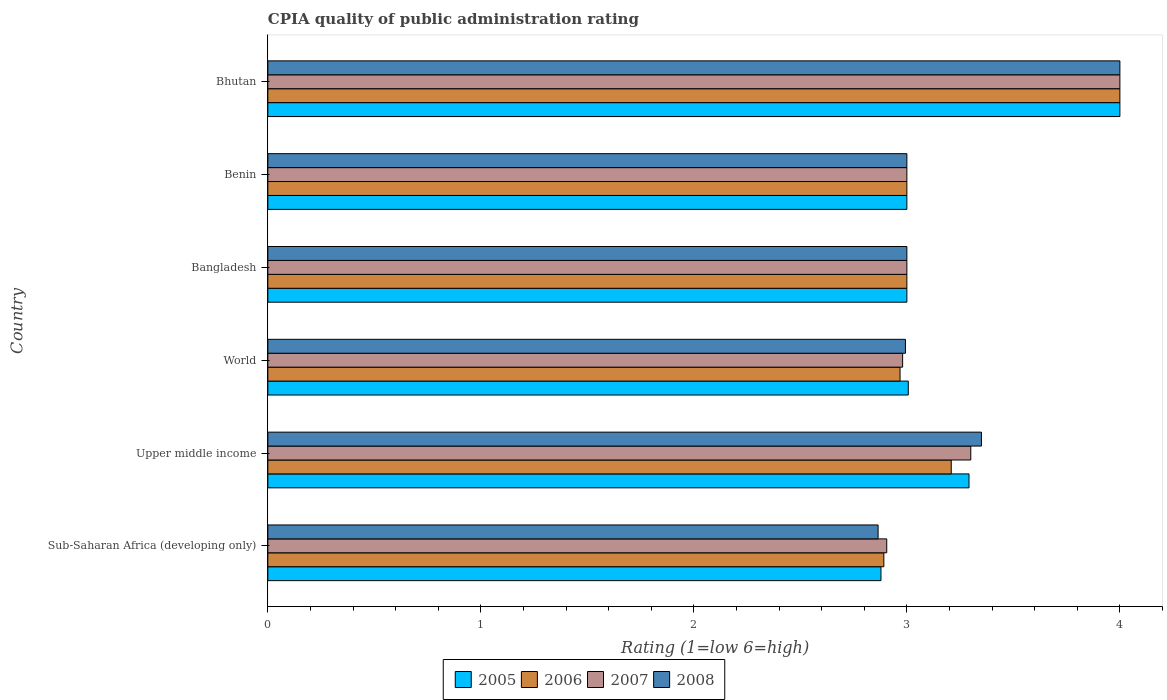Are the number of bars per tick equal to the number of legend labels?
Provide a short and direct response. Yes. How many bars are there on the 4th tick from the top?
Offer a terse response. 4. What is the label of the 2nd group of bars from the top?
Ensure brevity in your answer.  Benin. What is the CPIA rating in 2005 in World?
Your answer should be very brief. 3.01. Across all countries, what is the maximum CPIA rating in 2007?
Your answer should be compact. 4. Across all countries, what is the minimum CPIA rating in 2006?
Make the answer very short. 2.89. In which country was the CPIA rating in 2005 maximum?
Provide a succinct answer. Bhutan. In which country was the CPIA rating in 2007 minimum?
Your answer should be compact. Sub-Saharan Africa (developing only). What is the total CPIA rating in 2006 in the graph?
Your response must be concise. 19.07. What is the difference between the CPIA rating in 2007 in Sub-Saharan Africa (developing only) and that in Upper middle income?
Your response must be concise. -0.39. What is the difference between the CPIA rating in 2008 in Sub-Saharan Africa (developing only) and the CPIA rating in 2007 in Upper middle income?
Offer a terse response. -0.44. What is the average CPIA rating in 2006 per country?
Offer a terse response. 3.18. What is the difference between the CPIA rating in 2007 and CPIA rating in 2008 in Sub-Saharan Africa (developing only)?
Your answer should be very brief. 0.04. What is the ratio of the CPIA rating in 2006 in Sub-Saharan Africa (developing only) to that in Upper middle income?
Provide a succinct answer. 0.9. Is the CPIA rating in 2006 in Bhutan less than that in Upper middle income?
Your answer should be very brief. No. What is the difference between the highest and the second highest CPIA rating in 2006?
Offer a very short reply. 0.79. What is the difference between the highest and the lowest CPIA rating in 2005?
Your answer should be compact. 1.12. In how many countries, is the CPIA rating in 2008 greater than the average CPIA rating in 2008 taken over all countries?
Offer a very short reply. 2. Is the sum of the CPIA rating in 2008 in Sub-Saharan Africa (developing only) and World greater than the maximum CPIA rating in 2007 across all countries?
Give a very brief answer. Yes. Is it the case that in every country, the sum of the CPIA rating in 2007 and CPIA rating in 2006 is greater than the sum of CPIA rating in 2005 and CPIA rating in 2008?
Make the answer very short. No. What does the 2nd bar from the top in Bangladesh represents?
Keep it short and to the point. 2007. What does the 2nd bar from the bottom in Upper middle income represents?
Make the answer very short. 2006. How many countries are there in the graph?
Your answer should be very brief. 6. What is the difference between two consecutive major ticks on the X-axis?
Make the answer very short. 1. Where does the legend appear in the graph?
Your response must be concise. Bottom center. What is the title of the graph?
Your answer should be compact. CPIA quality of public administration rating. Does "1982" appear as one of the legend labels in the graph?
Your answer should be compact. No. What is the label or title of the Y-axis?
Your response must be concise. Country. What is the Rating (1=low 6=high) in 2005 in Sub-Saharan Africa (developing only)?
Your response must be concise. 2.88. What is the Rating (1=low 6=high) of 2006 in Sub-Saharan Africa (developing only)?
Keep it short and to the point. 2.89. What is the Rating (1=low 6=high) in 2007 in Sub-Saharan Africa (developing only)?
Your response must be concise. 2.91. What is the Rating (1=low 6=high) of 2008 in Sub-Saharan Africa (developing only)?
Keep it short and to the point. 2.86. What is the Rating (1=low 6=high) in 2005 in Upper middle income?
Make the answer very short. 3.29. What is the Rating (1=low 6=high) of 2006 in Upper middle income?
Keep it short and to the point. 3.21. What is the Rating (1=low 6=high) in 2008 in Upper middle income?
Your answer should be compact. 3.35. What is the Rating (1=low 6=high) in 2005 in World?
Provide a succinct answer. 3.01. What is the Rating (1=low 6=high) of 2006 in World?
Provide a succinct answer. 2.97. What is the Rating (1=low 6=high) in 2007 in World?
Make the answer very short. 2.98. What is the Rating (1=low 6=high) of 2008 in World?
Provide a succinct answer. 2.99. What is the Rating (1=low 6=high) in 2005 in Bangladesh?
Offer a terse response. 3. What is the Rating (1=low 6=high) in 2006 in Bangladesh?
Ensure brevity in your answer.  3. What is the Rating (1=low 6=high) of 2007 in Bangladesh?
Offer a very short reply. 3. What is the Rating (1=low 6=high) in 2008 in Bangladesh?
Provide a succinct answer. 3. What is the Rating (1=low 6=high) of 2006 in Benin?
Provide a short and direct response. 3. What is the Rating (1=low 6=high) of 2007 in Benin?
Your answer should be compact. 3. What is the Rating (1=low 6=high) of 2008 in Benin?
Offer a terse response. 3. What is the Rating (1=low 6=high) in 2005 in Bhutan?
Give a very brief answer. 4. What is the Rating (1=low 6=high) of 2007 in Bhutan?
Your answer should be very brief. 4. What is the Rating (1=low 6=high) of 2008 in Bhutan?
Provide a short and direct response. 4. Across all countries, what is the maximum Rating (1=low 6=high) in 2005?
Your answer should be very brief. 4. Across all countries, what is the maximum Rating (1=low 6=high) in 2007?
Your answer should be compact. 4. Across all countries, what is the maximum Rating (1=low 6=high) of 2008?
Ensure brevity in your answer.  4. Across all countries, what is the minimum Rating (1=low 6=high) of 2005?
Offer a terse response. 2.88. Across all countries, what is the minimum Rating (1=low 6=high) in 2006?
Make the answer very short. 2.89. Across all countries, what is the minimum Rating (1=low 6=high) in 2007?
Keep it short and to the point. 2.91. Across all countries, what is the minimum Rating (1=low 6=high) of 2008?
Your response must be concise. 2.86. What is the total Rating (1=low 6=high) of 2005 in the graph?
Make the answer very short. 19.18. What is the total Rating (1=low 6=high) of 2006 in the graph?
Keep it short and to the point. 19.07. What is the total Rating (1=low 6=high) of 2007 in the graph?
Your answer should be very brief. 19.19. What is the total Rating (1=low 6=high) in 2008 in the graph?
Provide a succinct answer. 19.21. What is the difference between the Rating (1=low 6=high) in 2005 in Sub-Saharan Africa (developing only) and that in Upper middle income?
Offer a terse response. -0.41. What is the difference between the Rating (1=low 6=high) in 2006 in Sub-Saharan Africa (developing only) and that in Upper middle income?
Your answer should be compact. -0.32. What is the difference between the Rating (1=low 6=high) in 2007 in Sub-Saharan Africa (developing only) and that in Upper middle income?
Your response must be concise. -0.39. What is the difference between the Rating (1=low 6=high) in 2008 in Sub-Saharan Africa (developing only) and that in Upper middle income?
Your answer should be compact. -0.49. What is the difference between the Rating (1=low 6=high) in 2005 in Sub-Saharan Africa (developing only) and that in World?
Your response must be concise. -0.13. What is the difference between the Rating (1=low 6=high) of 2006 in Sub-Saharan Africa (developing only) and that in World?
Provide a short and direct response. -0.08. What is the difference between the Rating (1=low 6=high) in 2007 in Sub-Saharan Africa (developing only) and that in World?
Provide a succinct answer. -0.07. What is the difference between the Rating (1=low 6=high) of 2008 in Sub-Saharan Africa (developing only) and that in World?
Your answer should be very brief. -0.13. What is the difference between the Rating (1=low 6=high) in 2005 in Sub-Saharan Africa (developing only) and that in Bangladesh?
Provide a short and direct response. -0.12. What is the difference between the Rating (1=low 6=high) of 2006 in Sub-Saharan Africa (developing only) and that in Bangladesh?
Provide a short and direct response. -0.11. What is the difference between the Rating (1=low 6=high) in 2007 in Sub-Saharan Africa (developing only) and that in Bangladesh?
Provide a short and direct response. -0.09. What is the difference between the Rating (1=low 6=high) of 2008 in Sub-Saharan Africa (developing only) and that in Bangladesh?
Your answer should be compact. -0.14. What is the difference between the Rating (1=low 6=high) of 2005 in Sub-Saharan Africa (developing only) and that in Benin?
Make the answer very short. -0.12. What is the difference between the Rating (1=low 6=high) in 2006 in Sub-Saharan Africa (developing only) and that in Benin?
Offer a very short reply. -0.11. What is the difference between the Rating (1=low 6=high) of 2007 in Sub-Saharan Africa (developing only) and that in Benin?
Offer a terse response. -0.09. What is the difference between the Rating (1=low 6=high) of 2008 in Sub-Saharan Africa (developing only) and that in Benin?
Offer a terse response. -0.14. What is the difference between the Rating (1=low 6=high) of 2005 in Sub-Saharan Africa (developing only) and that in Bhutan?
Your response must be concise. -1.12. What is the difference between the Rating (1=low 6=high) in 2006 in Sub-Saharan Africa (developing only) and that in Bhutan?
Provide a succinct answer. -1.11. What is the difference between the Rating (1=low 6=high) of 2007 in Sub-Saharan Africa (developing only) and that in Bhutan?
Offer a terse response. -1.09. What is the difference between the Rating (1=low 6=high) in 2008 in Sub-Saharan Africa (developing only) and that in Bhutan?
Offer a terse response. -1.14. What is the difference between the Rating (1=low 6=high) of 2005 in Upper middle income and that in World?
Give a very brief answer. 0.29. What is the difference between the Rating (1=low 6=high) in 2006 in Upper middle income and that in World?
Your response must be concise. 0.24. What is the difference between the Rating (1=low 6=high) of 2007 in Upper middle income and that in World?
Your response must be concise. 0.32. What is the difference between the Rating (1=low 6=high) of 2008 in Upper middle income and that in World?
Give a very brief answer. 0.36. What is the difference between the Rating (1=low 6=high) of 2005 in Upper middle income and that in Bangladesh?
Give a very brief answer. 0.29. What is the difference between the Rating (1=low 6=high) in 2006 in Upper middle income and that in Bangladesh?
Your answer should be very brief. 0.21. What is the difference between the Rating (1=low 6=high) of 2008 in Upper middle income and that in Bangladesh?
Keep it short and to the point. 0.35. What is the difference between the Rating (1=low 6=high) in 2005 in Upper middle income and that in Benin?
Offer a very short reply. 0.29. What is the difference between the Rating (1=low 6=high) in 2006 in Upper middle income and that in Benin?
Offer a terse response. 0.21. What is the difference between the Rating (1=low 6=high) in 2005 in Upper middle income and that in Bhutan?
Your answer should be compact. -0.71. What is the difference between the Rating (1=low 6=high) in 2006 in Upper middle income and that in Bhutan?
Keep it short and to the point. -0.79. What is the difference between the Rating (1=low 6=high) of 2007 in Upper middle income and that in Bhutan?
Make the answer very short. -0.7. What is the difference between the Rating (1=low 6=high) in 2008 in Upper middle income and that in Bhutan?
Your response must be concise. -0.65. What is the difference between the Rating (1=low 6=high) of 2005 in World and that in Bangladesh?
Provide a succinct answer. 0.01. What is the difference between the Rating (1=low 6=high) in 2006 in World and that in Bangladesh?
Your response must be concise. -0.03. What is the difference between the Rating (1=low 6=high) in 2007 in World and that in Bangladesh?
Your answer should be very brief. -0.02. What is the difference between the Rating (1=low 6=high) in 2008 in World and that in Bangladesh?
Your response must be concise. -0.01. What is the difference between the Rating (1=low 6=high) in 2005 in World and that in Benin?
Make the answer very short. 0.01. What is the difference between the Rating (1=low 6=high) of 2006 in World and that in Benin?
Your answer should be very brief. -0.03. What is the difference between the Rating (1=low 6=high) in 2007 in World and that in Benin?
Offer a terse response. -0.02. What is the difference between the Rating (1=low 6=high) in 2008 in World and that in Benin?
Provide a short and direct response. -0.01. What is the difference between the Rating (1=low 6=high) in 2005 in World and that in Bhutan?
Provide a succinct answer. -0.99. What is the difference between the Rating (1=low 6=high) of 2006 in World and that in Bhutan?
Provide a succinct answer. -1.03. What is the difference between the Rating (1=low 6=high) in 2007 in World and that in Bhutan?
Ensure brevity in your answer.  -1.02. What is the difference between the Rating (1=low 6=high) of 2008 in World and that in Bhutan?
Your response must be concise. -1.01. What is the difference between the Rating (1=low 6=high) of 2006 in Bangladesh and that in Benin?
Make the answer very short. 0. What is the difference between the Rating (1=low 6=high) of 2008 in Bangladesh and that in Benin?
Make the answer very short. 0. What is the difference between the Rating (1=low 6=high) in 2005 in Bangladesh and that in Bhutan?
Make the answer very short. -1. What is the difference between the Rating (1=low 6=high) in 2008 in Bangladesh and that in Bhutan?
Ensure brevity in your answer.  -1. What is the difference between the Rating (1=low 6=high) in 2005 in Benin and that in Bhutan?
Your response must be concise. -1. What is the difference between the Rating (1=low 6=high) of 2006 in Benin and that in Bhutan?
Your response must be concise. -1. What is the difference between the Rating (1=low 6=high) of 2005 in Sub-Saharan Africa (developing only) and the Rating (1=low 6=high) of 2006 in Upper middle income?
Provide a short and direct response. -0.33. What is the difference between the Rating (1=low 6=high) of 2005 in Sub-Saharan Africa (developing only) and the Rating (1=low 6=high) of 2007 in Upper middle income?
Offer a very short reply. -0.42. What is the difference between the Rating (1=low 6=high) in 2005 in Sub-Saharan Africa (developing only) and the Rating (1=low 6=high) in 2008 in Upper middle income?
Offer a terse response. -0.47. What is the difference between the Rating (1=low 6=high) in 2006 in Sub-Saharan Africa (developing only) and the Rating (1=low 6=high) in 2007 in Upper middle income?
Your answer should be compact. -0.41. What is the difference between the Rating (1=low 6=high) in 2006 in Sub-Saharan Africa (developing only) and the Rating (1=low 6=high) in 2008 in Upper middle income?
Make the answer very short. -0.46. What is the difference between the Rating (1=low 6=high) in 2007 in Sub-Saharan Africa (developing only) and the Rating (1=low 6=high) in 2008 in Upper middle income?
Provide a succinct answer. -0.44. What is the difference between the Rating (1=low 6=high) of 2005 in Sub-Saharan Africa (developing only) and the Rating (1=low 6=high) of 2006 in World?
Give a very brief answer. -0.09. What is the difference between the Rating (1=low 6=high) in 2005 in Sub-Saharan Africa (developing only) and the Rating (1=low 6=high) in 2007 in World?
Give a very brief answer. -0.1. What is the difference between the Rating (1=low 6=high) in 2005 in Sub-Saharan Africa (developing only) and the Rating (1=low 6=high) in 2008 in World?
Make the answer very short. -0.12. What is the difference between the Rating (1=low 6=high) in 2006 in Sub-Saharan Africa (developing only) and the Rating (1=low 6=high) in 2007 in World?
Offer a very short reply. -0.09. What is the difference between the Rating (1=low 6=high) of 2006 in Sub-Saharan Africa (developing only) and the Rating (1=low 6=high) of 2008 in World?
Ensure brevity in your answer.  -0.1. What is the difference between the Rating (1=low 6=high) of 2007 in Sub-Saharan Africa (developing only) and the Rating (1=low 6=high) of 2008 in World?
Offer a terse response. -0.09. What is the difference between the Rating (1=low 6=high) of 2005 in Sub-Saharan Africa (developing only) and the Rating (1=low 6=high) of 2006 in Bangladesh?
Ensure brevity in your answer.  -0.12. What is the difference between the Rating (1=low 6=high) in 2005 in Sub-Saharan Africa (developing only) and the Rating (1=low 6=high) in 2007 in Bangladesh?
Give a very brief answer. -0.12. What is the difference between the Rating (1=low 6=high) in 2005 in Sub-Saharan Africa (developing only) and the Rating (1=low 6=high) in 2008 in Bangladesh?
Give a very brief answer. -0.12. What is the difference between the Rating (1=low 6=high) in 2006 in Sub-Saharan Africa (developing only) and the Rating (1=low 6=high) in 2007 in Bangladesh?
Offer a terse response. -0.11. What is the difference between the Rating (1=low 6=high) in 2006 in Sub-Saharan Africa (developing only) and the Rating (1=low 6=high) in 2008 in Bangladesh?
Offer a terse response. -0.11. What is the difference between the Rating (1=low 6=high) in 2007 in Sub-Saharan Africa (developing only) and the Rating (1=low 6=high) in 2008 in Bangladesh?
Make the answer very short. -0.09. What is the difference between the Rating (1=low 6=high) in 2005 in Sub-Saharan Africa (developing only) and the Rating (1=low 6=high) in 2006 in Benin?
Offer a very short reply. -0.12. What is the difference between the Rating (1=low 6=high) of 2005 in Sub-Saharan Africa (developing only) and the Rating (1=low 6=high) of 2007 in Benin?
Your response must be concise. -0.12. What is the difference between the Rating (1=low 6=high) in 2005 in Sub-Saharan Africa (developing only) and the Rating (1=low 6=high) in 2008 in Benin?
Ensure brevity in your answer.  -0.12. What is the difference between the Rating (1=low 6=high) of 2006 in Sub-Saharan Africa (developing only) and the Rating (1=low 6=high) of 2007 in Benin?
Ensure brevity in your answer.  -0.11. What is the difference between the Rating (1=low 6=high) in 2006 in Sub-Saharan Africa (developing only) and the Rating (1=low 6=high) in 2008 in Benin?
Offer a terse response. -0.11. What is the difference between the Rating (1=low 6=high) of 2007 in Sub-Saharan Africa (developing only) and the Rating (1=low 6=high) of 2008 in Benin?
Provide a short and direct response. -0.09. What is the difference between the Rating (1=low 6=high) in 2005 in Sub-Saharan Africa (developing only) and the Rating (1=low 6=high) in 2006 in Bhutan?
Offer a very short reply. -1.12. What is the difference between the Rating (1=low 6=high) in 2005 in Sub-Saharan Africa (developing only) and the Rating (1=low 6=high) in 2007 in Bhutan?
Keep it short and to the point. -1.12. What is the difference between the Rating (1=low 6=high) of 2005 in Sub-Saharan Africa (developing only) and the Rating (1=low 6=high) of 2008 in Bhutan?
Give a very brief answer. -1.12. What is the difference between the Rating (1=low 6=high) in 2006 in Sub-Saharan Africa (developing only) and the Rating (1=low 6=high) in 2007 in Bhutan?
Provide a succinct answer. -1.11. What is the difference between the Rating (1=low 6=high) in 2006 in Sub-Saharan Africa (developing only) and the Rating (1=low 6=high) in 2008 in Bhutan?
Make the answer very short. -1.11. What is the difference between the Rating (1=low 6=high) in 2007 in Sub-Saharan Africa (developing only) and the Rating (1=low 6=high) in 2008 in Bhutan?
Provide a succinct answer. -1.09. What is the difference between the Rating (1=low 6=high) in 2005 in Upper middle income and the Rating (1=low 6=high) in 2006 in World?
Offer a terse response. 0.32. What is the difference between the Rating (1=low 6=high) of 2005 in Upper middle income and the Rating (1=low 6=high) of 2007 in World?
Provide a succinct answer. 0.31. What is the difference between the Rating (1=low 6=high) of 2005 in Upper middle income and the Rating (1=low 6=high) of 2008 in World?
Your answer should be very brief. 0.3. What is the difference between the Rating (1=low 6=high) of 2006 in Upper middle income and the Rating (1=low 6=high) of 2007 in World?
Ensure brevity in your answer.  0.23. What is the difference between the Rating (1=low 6=high) of 2006 in Upper middle income and the Rating (1=low 6=high) of 2008 in World?
Provide a succinct answer. 0.21. What is the difference between the Rating (1=low 6=high) in 2007 in Upper middle income and the Rating (1=low 6=high) in 2008 in World?
Offer a very short reply. 0.31. What is the difference between the Rating (1=low 6=high) in 2005 in Upper middle income and the Rating (1=low 6=high) in 2006 in Bangladesh?
Offer a terse response. 0.29. What is the difference between the Rating (1=low 6=high) in 2005 in Upper middle income and the Rating (1=low 6=high) in 2007 in Bangladesh?
Your answer should be compact. 0.29. What is the difference between the Rating (1=low 6=high) of 2005 in Upper middle income and the Rating (1=low 6=high) of 2008 in Bangladesh?
Give a very brief answer. 0.29. What is the difference between the Rating (1=low 6=high) in 2006 in Upper middle income and the Rating (1=low 6=high) in 2007 in Bangladesh?
Keep it short and to the point. 0.21. What is the difference between the Rating (1=low 6=high) in 2006 in Upper middle income and the Rating (1=low 6=high) in 2008 in Bangladesh?
Your response must be concise. 0.21. What is the difference between the Rating (1=low 6=high) of 2005 in Upper middle income and the Rating (1=low 6=high) of 2006 in Benin?
Your response must be concise. 0.29. What is the difference between the Rating (1=low 6=high) in 2005 in Upper middle income and the Rating (1=low 6=high) in 2007 in Benin?
Your response must be concise. 0.29. What is the difference between the Rating (1=low 6=high) of 2005 in Upper middle income and the Rating (1=low 6=high) of 2008 in Benin?
Give a very brief answer. 0.29. What is the difference between the Rating (1=low 6=high) of 2006 in Upper middle income and the Rating (1=low 6=high) of 2007 in Benin?
Make the answer very short. 0.21. What is the difference between the Rating (1=low 6=high) of 2006 in Upper middle income and the Rating (1=low 6=high) of 2008 in Benin?
Provide a succinct answer. 0.21. What is the difference between the Rating (1=low 6=high) of 2007 in Upper middle income and the Rating (1=low 6=high) of 2008 in Benin?
Ensure brevity in your answer.  0.3. What is the difference between the Rating (1=low 6=high) of 2005 in Upper middle income and the Rating (1=low 6=high) of 2006 in Bhutan?
Your answer should be very brief. -0.71. What is the difference between the Rating (1=low 6=high) in 2005 in Upper middle income and the Rating (1=low 6=high) in 2007 in Bhutan?
Offer a terse response. -0.71. What is the difference between the Rating (1=low 6=high) of 2005 in Upper middle income and the Rating (1=low 6=high) of 2008 in Bhutan?
Keep it short and to the point. -0.71. What is the difference between the Rating (1=low 6=high) in 2006 in Upper middle income and the Rating (1=low 6=high) in 2007 in Bhutan?
Offer a terse response. -0.79. What is the difference between the Rating (1=low 6=high) in 2006 in Upper middle income and the Rating (1=low 6=high) in 2008 in Bhutan?
Ensure brevity in your answer.  -0.79. What is the difference between the Rating (1=low 6=high) of 2005 in World and the Rating (1=low 6=high) of 2006 in Bangladesh?
Offer a very short reply. 0.01. What is the difference between the Rating (1=low 6=high) of 2005 in World and the Rating (1=low 6=high) of 2007 in Bangladesh?
Ensure brevity in your answer.  0.01. What is the difference between the Rating (1=low 6=high) in 2005 in World and the Rating (1=low 6=high) in 2008 in Bangladesh?
Your response must be concise. 0.01. What is the difference between the Rating (1=low 6=high) in 2006 in World and the Rating (1=low 6=high) in 2007 in Bangladesh?
Keep it short and to the point. -0.03. What is the difference between the Rating (1=low 6=high) of 2006 in World and the Rating (1=low 6=high) of 2008 in Bangladesh?
Keep it short and to the point. -0.03. What is the difference between the Rating (1=low 6=high) in 2007 in World and the Rating (1=low 6=high) in 2008 in Bangladesh?
Your answer should be compact. -0.02. What is the difference between the Rating (1=low 6=high) in 2005 in World and the Rating (1=low 6=high) in 2006 in Benin?
Provide a succinct answer. 0.01. What is the difference between the Rating (1=low 6=high) of 2005 in World and the Rating (1=low 6=high) of 2007 in Benin?
Make the answer very short. 0.01. What is the difference between the Rating (1=low 6=high) in 2005 in World and the Rating (1=low 6=high) in 2008 in Benin?
Provide a succinct answer. 0.01. What is the difference between the Rating (1=low 6=high) of 2006 in World and the Rating (1=low 6=high) of 2007 in Benin?
Ensure brevity in your answer.  -0.03. What is the difference between the Rating (1=low 6=high) of 2006 in World and the Rating (1=low 6=high) of 2008 in Benin?
Your answer should be very brief. -0.03. What is the difference between the Rating (1=low 6=high) in 2007 in World and the Rating (1=low 6=high) in 2008 in Benin?
Your answer should be very brief. -0.02. What is the difference between the Rating (1=low 6=high) of 2005 in World and the Rating (1=low 6=high) of 2006 in Bhutan?
Your response must be concise. -0.99. What is the difference between the Rating (1=low 6=high) in 2005 in World and the Rating (1=low 6=high) in 2007 in Bhutan?
Your answer should be compact. -0.99. What is the difference between the Rating (1=low 6=high) in 2005 in World and the Rating (1=low 6=high) in 2008 in Bhutan?
Make the answer very short. -0.99. What is the difference between the Rating (1=low 6=high) of 2006 in World and the Rating (1=low 6=high) of 2007 in Bhutan?
Make the answer very short. -1.03. What is the difference between the Rating (1=low 6=high) in 2006 in World and the Rating (1=low 6=high) in 2008 in Bhutan?
Your response must be concise. -1.03. What is the difference between the Rating (1=low 6=high) of 2007 in World and the Rating (1=low 6=high) of 2008 in Bhutan?
Your answer should be compact. -1.02. What is the difference between the Rating (1=low 6=high) in 2005 in Bangladesh and the Rating (1=low 6=high) in 2007 in Benin?
Your answer should be very brief. 0. What is the difference between the Rating (1=low 6=high) in 2006 in Bangladesh and the Rating (1=low 6=high) in 2007 in Benin?
Keep it short and to the point. 0. What is the difference between the Rating (1=low 6=high) of 2006 in Bangladesh and the Rating (1=low 6=high) of 2008 in Benin?
Your response must be concise. 0. What is the difference between the Rating (1=low 6=high) in 2005 in Bangladesh and the Rating (1=low 6=high) in 2007 in Bhutan?
Give a very brief answer. -1. What is the difference between the Rating (1=low 6=high) of 2005 in Bangladesh and the Rating (1=low 6=high) of 2008 in Bhutan?
Offer a very short reply. -1. What is the difference between the Rating (1=low 6=high) of 2006 in Bangladesh and the Rating (1=low 6=high) of 2008 in Bhutan?
Make the answer very short. -1. What is the difference between the Rating (1=low 6=high) of 2007 in Bangladesh and the Rating (1=low 6=high) of 2008 in Bhutan?
Your answer should be compact. -1. What is the difference between the Rating (1=low 6=high) in 2005 in Benin and the Rating (1=low 6=high) in 2006 in Bhutan?
Your answer should be compact. -1. What is the difference between the Rating (1=low 6=high) in 2005 in Benin and the Rating (1=low 6=high) in 2008 in Bhutan?
Your answer should be very brief. -1. What is the difference between the Rating (1=low 6=high) of 2007 in Benin and the Rating (1=low 6=high) of 2008 in Bhutan?
Give a very brief answer. -1. What is the average Rating (1=low 6=high) of 2005 per country?
Your answer should be compact. 3.2. What is the average Rating (1=low 6=high) in 2006 per country?
Provide a short and direct response. 3.18. What is the average Rating (1=low 6=high) of 2007 per country?
Offer a terse response. 3.2. What is the average Rating (1=low 6=high) of 2008 per country?
Your answer should be compact. 3.2. What is the difference between the Rating (1=low 6=high) in 2005 and Rating (1=low 6=high) in 2006 in Sub-Saharan Africa (developing only)?
Ensure brevity in your answer.  -0.01. What is the difference between the Rating (1=low 6=high) in 2005 and Rating (1=low 6=high) in 2007 in Sub-Saharan Africa (developing only)?
Your answer should be very brief. -0.03. What is the difference between the Rating (1=low 6=high) of 2005 and Rating (1=low 6=high) of 2008 in Sub-Saharan Africa (developing only)?
Offer a very short reply. 0.01. What is the difference between the Rating (1=low 6=high) in 2006 and Rating (1=low 6=high) in 2007 in Sub-Saharan Africa (developing only)?
Ensure brevity in your answer.  -0.01. What is the difference between the Rating (1=low 6=high) in 2006 and Rating (1=low 6=high) in 2008 in Sub-Saharan Africa (developing only)?
Your answer should be compact. 0.03. What is the difference between the Rating (1=low 6=high) of 2007 and Rating (1=low 6=high) of 2008 in Sub-Saharan Africa (developing only)?
Your answer should be compact. 0.04. What is the difference between the Rating (1=low 6=high) in 2005 and Rating (1=low 6=high) in 2006 in Upper middle income?
Your answer should be compact. 0.08. What is the difference between the Rating (1=low 6=high) in 2005 and Rating (1=low 6=high) in 2007 in Upper middle income?
Ensure brevity in your answer.  -0.01. What is the difference between the Rating (1=low 6=high) of 2005 and Rating (1=low 6=high) of 2008 in Upper middle income?
Offer a terse response. -0.06. What is the difference between the Rating (1=low 6=high) of 2006 and Rating (1=low 6=high) of 2007 in Upper middle income?
Provide a short and direct response. -0.09. What is the difference between the Rating (1=low 6=high) of 2006 and Rating (1=low 6=high) of 2008 in Upper middle income?
Your answer should be very brief. -0.14. What is the difference between the Rating (1=low 6=high) of 2007 and Rating (1=low 6=high) of 2008 in Upper middle income?
Give a very brief answer. -0.05. What is the difference between the Rating (1=low 6=high) of 2005 and Rating (1=low 6=high) of 2006 in World?
Your answer should be compact. 0.04. What is the difference between the Rating (1=low 6=high) in 2005 and Rating (1=low 6=high) in 2007 in World?
Provide a short and direct response. 0.03. What is the difference between the Rating (1=low 6=high) of 2005 and Rating (1=low 6=high) of 2008 in World?
Your answer should be compact. 0.01. What is the difference between the Rating (1=low 6=high) in 2006 and Rating (1=low 6=high) in 2007 in World?
Your response must be concise. -0.01. What is the difference between the Rating (1=low 6=high) in 2006 and Rating (1=low 6=high) in 2008 in World?
Offer a very short reply. -0.03. What is the difference between the Rating (1=low 6=high) in 2007 and Rating (1=low 6=high) in 2008 in World?
Keep it short and to the point. -0.01. What is the difference between the Rating (1=low 6=high) of 2005 and Rating (1=low 6=high) of 2006 in Bangladesh?
Provide a short and direct response. 0. What is the difference between the Rating (1=low 6=high) of 2005 and Rating (1=low 6=high) of 2008 in Bangladesh?
Give a very brief answer. 0. What is the difference between the Rating (1=low 6=high) in 2006 and Rating (1=low 6=high) in 2008 in Bangladesh?
Your response must be concise. 0. What is the difference between the Rating (1=low 6=high) of 2005 and Rating (1=low 6=high) of 2007 in Benin?
Offer a very short reply. 0. What is the difference between the Rating (1=low 6=high) in 2006 and Rating (1=low 6=high) in 2007 in Benin?
Make the answer very short. 0. What is the difference between the Rating (1=low 6=high) in 2005 and Rating (1=low 6=high) in 2006 in Bhutan?
Provide a succinct answer. 0. What is the difference between the Rating (1=low 6=high) in 2005 and Rating (1=low 6=high) in 2008 in Bhutan?
Your answer should be very brief. 0. What is the difference between the Rating (1=low 6=high) of 2007 and Rating (1=low 6=high) of 2008 in Bhutan?
Offer a terse response. 0. What is the ratio of the Rating (1=low 6=high) of 2005 in Sub-Saharan Africa (developing only) to that in Upper middle income?
Give a very brief answer. 0.87. What is the ratio of the Rating (1=low 6=high) of 2006 in Sub-Saharan Africa (developing only) to that in Upper middle income?
Make the answer very short. 0.9. What is the ratio of the Rating (1=low 6=high) of 2007 in Sub-Saharan Africa (developing only) to that in Upper middle income?
Give a very brief answer. 0.88. What is the ratio of the Rating (1=low 6=high) of 2008 in Sub-Saharan Africa (developing only) to that in Upper middle income?
Keep it short and to the point. 0.86. What is the ratio of the Rating (1=low 6=high) of 2005 in Sub-Saharan Africa (developing only) to that in World?
Give a very brief answer. 0.96. What is the ratio of the Rating (1=low 6=high) of 2006 in Sub-Saharan Africa (developing only) to that in World?
Your answer should be very brief. 0.97. What is the ratio of the Rating (1=low 6=high) in 2008 in Sub-Saharan Africa (developing only) to that in World?
Your answer should be very brief. 0.96. What is the ratio of the Rating (1=low 6=high) of 2005 in Sub-Saharan Africa (developing only) to that in Bangladesh?
Your answer should be compact. 0.96. What is the ratio of the Rating (1=low 6=high) of 2007 in Sub-Saharan Africa (developing only) to that in Bangladesh?
Offer a terse response. 0.97. What is the ratio of the Rating (1=low 6=high) of 2008 in Sub-Saharan Africa (developing only) to that in Bangladesh?
Your answer should be compact. 0.95. What is the ratio of the Rating (1=low 6=high) of 2005 in Sub-Saharan Africa (developing only) to that in Benin?
Your answer should be compact. 0.96. What is the ratio of the Rating (1=low 6=high) in 2006 in Sub-Saharan Africa (developing only) to that in Benin?
Offer a very short reply. 0.96. What is the ratio of the Rating (1=low 6=high) in 2007 in Sub-Saharan Africa (developing only) to that in Benin?
Provide a short and direct response. 0.97. What is the ratio of the Rating (1=low 6=high) in 2008 in Sub-Saharan Africa (developing only) to that in Benin?
Offer a very short reply. 0.95. What is the ratio of the Rating (1=low 6=high) of 2005 in Sub-Saharan Africa (developing only) to that in Bhutan?
Make the answer very short. 0.72. What is the ratio of the Rating (1=low 6=high) in 2006 in Sub-Saharan Africa (developing only) to that in Bhutan?
Your answer should be very brief. 0.72. What is the ratio of the Rating (1=low 6=high) of 2007 in Sub-Saharan Africa (developing only) to that in Bhutan?
Give a very brief answer. 0.73. What is the ratio of the Rating (1=low 6=high) in 2008 in Sub-Saharan Africa (developing only) to that in Bhutan?
Provide a succinct answer. 0.72. What is the ratio of the Rating (1=low 6=high) of 2005 in Upper middle income to that in World?
Provide a short and direct response. 1.09. What is the ratio of the Rating (1=low 6=high) of 2006 in Upper middle income to that in World?
Your answer should be very brief. 1.08. What is the ratio of the Rating (1=low 6=high) in 2007 in Upper middle income to that in World?
Provide a succinct answer. 1.11. What is the ratio of the Rating (1=low 6=high) in 2008 in Upper middle income to that in World?
Your response must be concise. 1.12. What is the ratio of the Rating (1=low 6=high) of 2005 in Upper middle income to that in Bangladesh?
Make the answer very short. 1.1. What is the ratio of the Rating (1=low 6=high) of 2006 in Upper middle income to that in Bangladesh?
Provide a short and direct response. 1.07. What is the ratio of the Rating (1=low 6=high) of 2007 in Upper middle income to that in Bangladesh?
Offer a terse response. 1.1. What is the ratio of the Rating (1=low 6=high) in 2008 in Upper middle income to that in Bangladesh?
Keep it short and to the point. 1.12. What is the ratio of the Rating (1=low 6=high) of 2005 in Upper middle income to that in Benin?
Your answer should be very brief. 1.1. What is the ratio of the Rating (1=low 6=high) of 2006 in Upper middle income to that in Benin?
Make the answer very short. 1.07. What is the ratio of the Rating (1=low 6=high) of 2007 in Upper middle income to that in Benin?
Make the answer very short. 1.1. What is the ratio of the Rating (1=low 6=high) of 2008 in Upper middle income to that in Benin?
Offer a terse response. 1.12. What is the ratio of the Rating (1=low 6=high) in 2005 in Upper middle income to that in Bhutan?
Provide a short and direct response. 0.82. What is the ratio of the Rating (1=low 6=high) of 2006 in Upper middle income to that in Bhutan?
Your response must be concise. 0.8. What is the ratio of the Rating (1=low 6=high) in 2007 in Upper middle income to that in Bhutan?
Keep it short and to the point. 0.82. What is the ratio of the Rating (1=low 6=high) in 2008 in Upper middle income to that in Bhutan?
Provide a short and direct response. 0.84. What is the ratio of the Rating (1=low 6=high) in 2006 in World to that in Bangladesh?
Give a very brief answer. 0.99. What is the ratio of the Rating (1=low 6=high) in 2008 in World to that in Bangladesh?
Your response must be concise. 1. What is the ratio of the Rating (1=low 6=high) in 2006 in World to that in Benin?
Ensure brevity in your answer.  0.99. What is the ratio of the Rating (1=low 6=high) of 2007 in World to that in Benin?
Your answer should be compact. 0.99. What is the ratio of the Rating (1=low 6=high) of 2005 in World to that in Bhutan?
Provide a succinct answer. 0.75. What is the ratio of the Rating (1=low 6=high) in 2006 in World to that in Bhutan?
Provide a short and direct response. 0.74. What is the ratio of the Rating (1=low 6=high) in 2007 in World to that in Bhutan?
Offer a very short reply. 0.74. What is the ratio of the Rating (1=low 6=high) of 2008 in World to that in Bhutan?
Give a very brief answer. 0.75. What is the ratio of the Rating (1=low 6=high) of 2005 in Bangladesh to that in Benin?
Provide a succinct answer. 1. What is the ratio of the Rating (1=low 6=high) of 2007 in Bangladesh to that in Benin?
Your response must be concise. 1. What is the ratio of the Rating (1=low 6=high) of 2005 in Bangladesh to that in Bhutan?
Give a very brief answer. 0.75. What is the ratio of the Rating (1=low 6=high) in 2008 in Bangladesh to that in Bhutan?
Make the answer very short. 0.75. What is the ratio of the Rating (1=low 6=high) of 2007 in Benin to that in Bhutan?
Your response must be concise. 0.75. What is the ratio of the Rating (1=low 6=high) in 2008 in Benin to that in Bhutan?
Provide a succinct answer. 0.75. What is the difference between the highest and the second highest Rating (1=low 6=high) in 2005?
Give a very brief answer. 0.71. What is the difference between the highest and the second highest Rating (1=low 6=high) in 2006?
Give a very brief answer. 0.79. What is the difference between the highest and the second highest Rating (1=low 6=high) of 2007?
Keep it short and to the point. 0.7. What is the difference between the highest and the second highest Rating (1=low 6=high) in 2008?
Your response must be concise. 0.65. What is the difference between the highest and the lowest Rating (1=low 6=high) in 2005?
Offer a terse response. 1.12. What is the difference between the highest and the lowest Rating (1=low 6=high) of 2006?
Your answer should be very brief. 1.11. What is the difference between the highest and the lowest Rating (1=low 6=high) in 2007?
Give a very brief answer. 1.09. What is the difference between the highest and the lowest Rating (1=low 6=high) in 2008?
Your answer should be very brief. 1.14. 